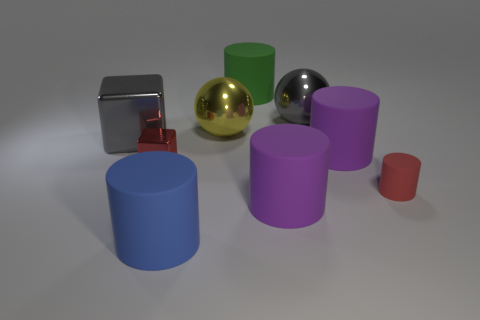The tiny metal object that is the same color as the tiny cylinder is what shape?
Your answer should be compact. Cube. What material is the small red object to the left of the big purple rubber cylinder that is behind the red rubber cylinder?
Make the answer very short. Metal. How many things are tiny red metallic objects or big purple rubber cylinders that are behind the red rubber thing?
Provide a succinct answer. 2. There is a yellow ball that is the same material as the big gray sphere; what is its size?
Your answer should be very brief. Large. Is the number of large gray things that are right of the large green rubber cylinder greater than the number of tiny red cylinders?
Offer a very short reply. No. There is a thing that is both on the left side of the blue cylinder and to the right of the gray metal block; what size is it?
Keep it short and to the point. Small. There is a gray thing that is the same shape as the yellow metallic thing; what is its material?
Your answer should be very brief. Metal. Are there an equal number of red cubes and small brown matte cubes?
Your answer should be compact. No. There is a gray metal thing to the left of the blue cylinder; does it have the same size as the red block?
Ensure brevity in your answer.  No. There is a object that is both behind the tiny red shiny block and on the left side of the blue cylinder; what color is it?
Provide a succinct answer. Gray. 